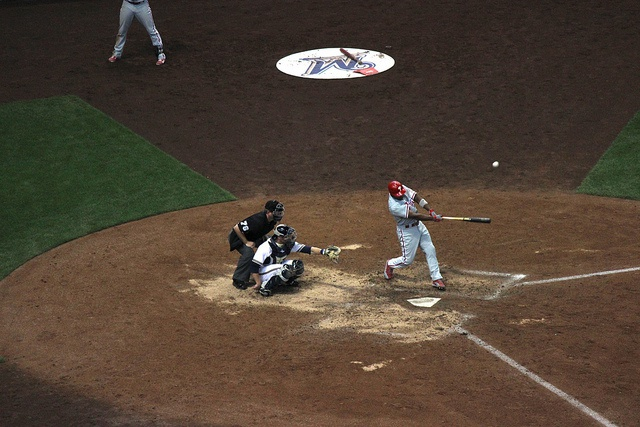Describe the objects in this image and their specific colors. I can see people in black, darkgray, gray, and lightgray tones, people in black, white, gray, and darkgray tones, people in black, gray, and maroon tones, people in black and gray tones, and baseball glove in black, gray, maroon, tan, and khaki tones in this image. 